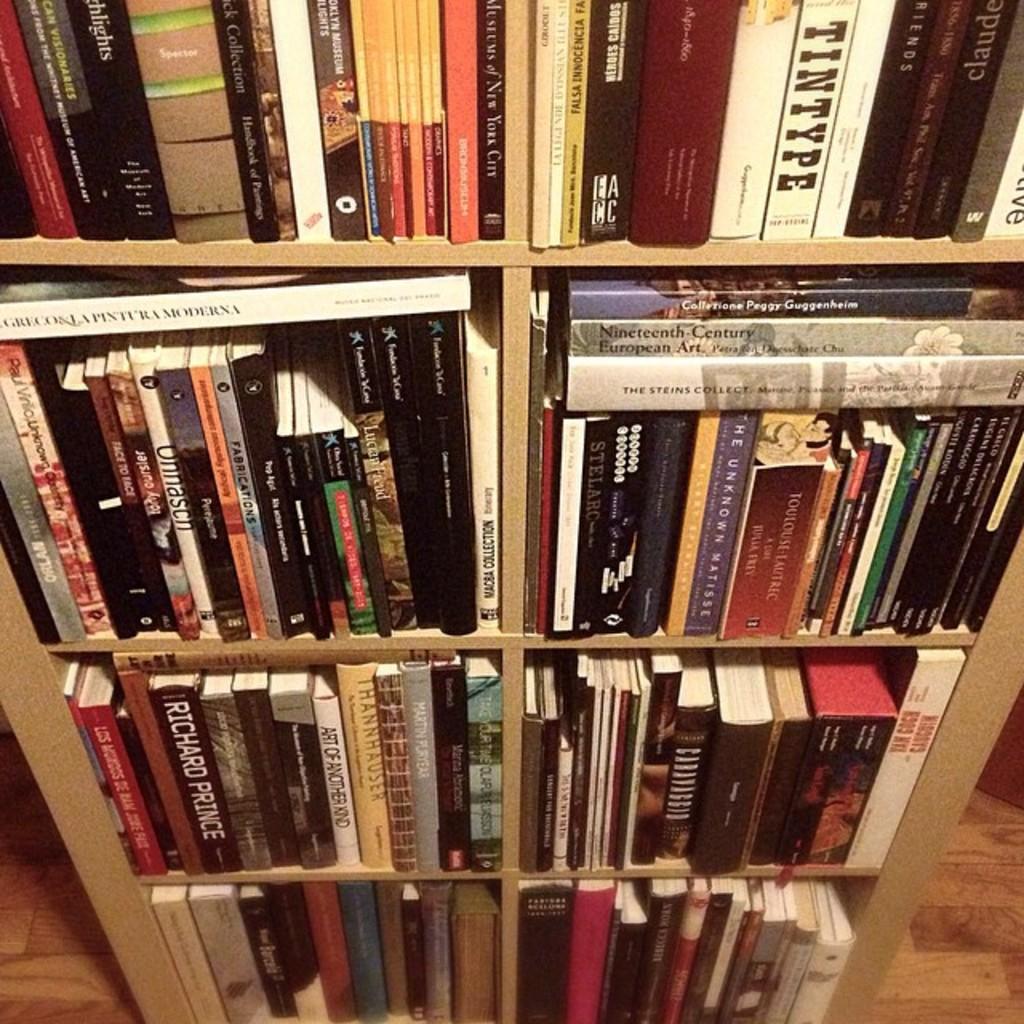What is the title of the white book with black writing on the top?
Your response must be concise. Tintype. 